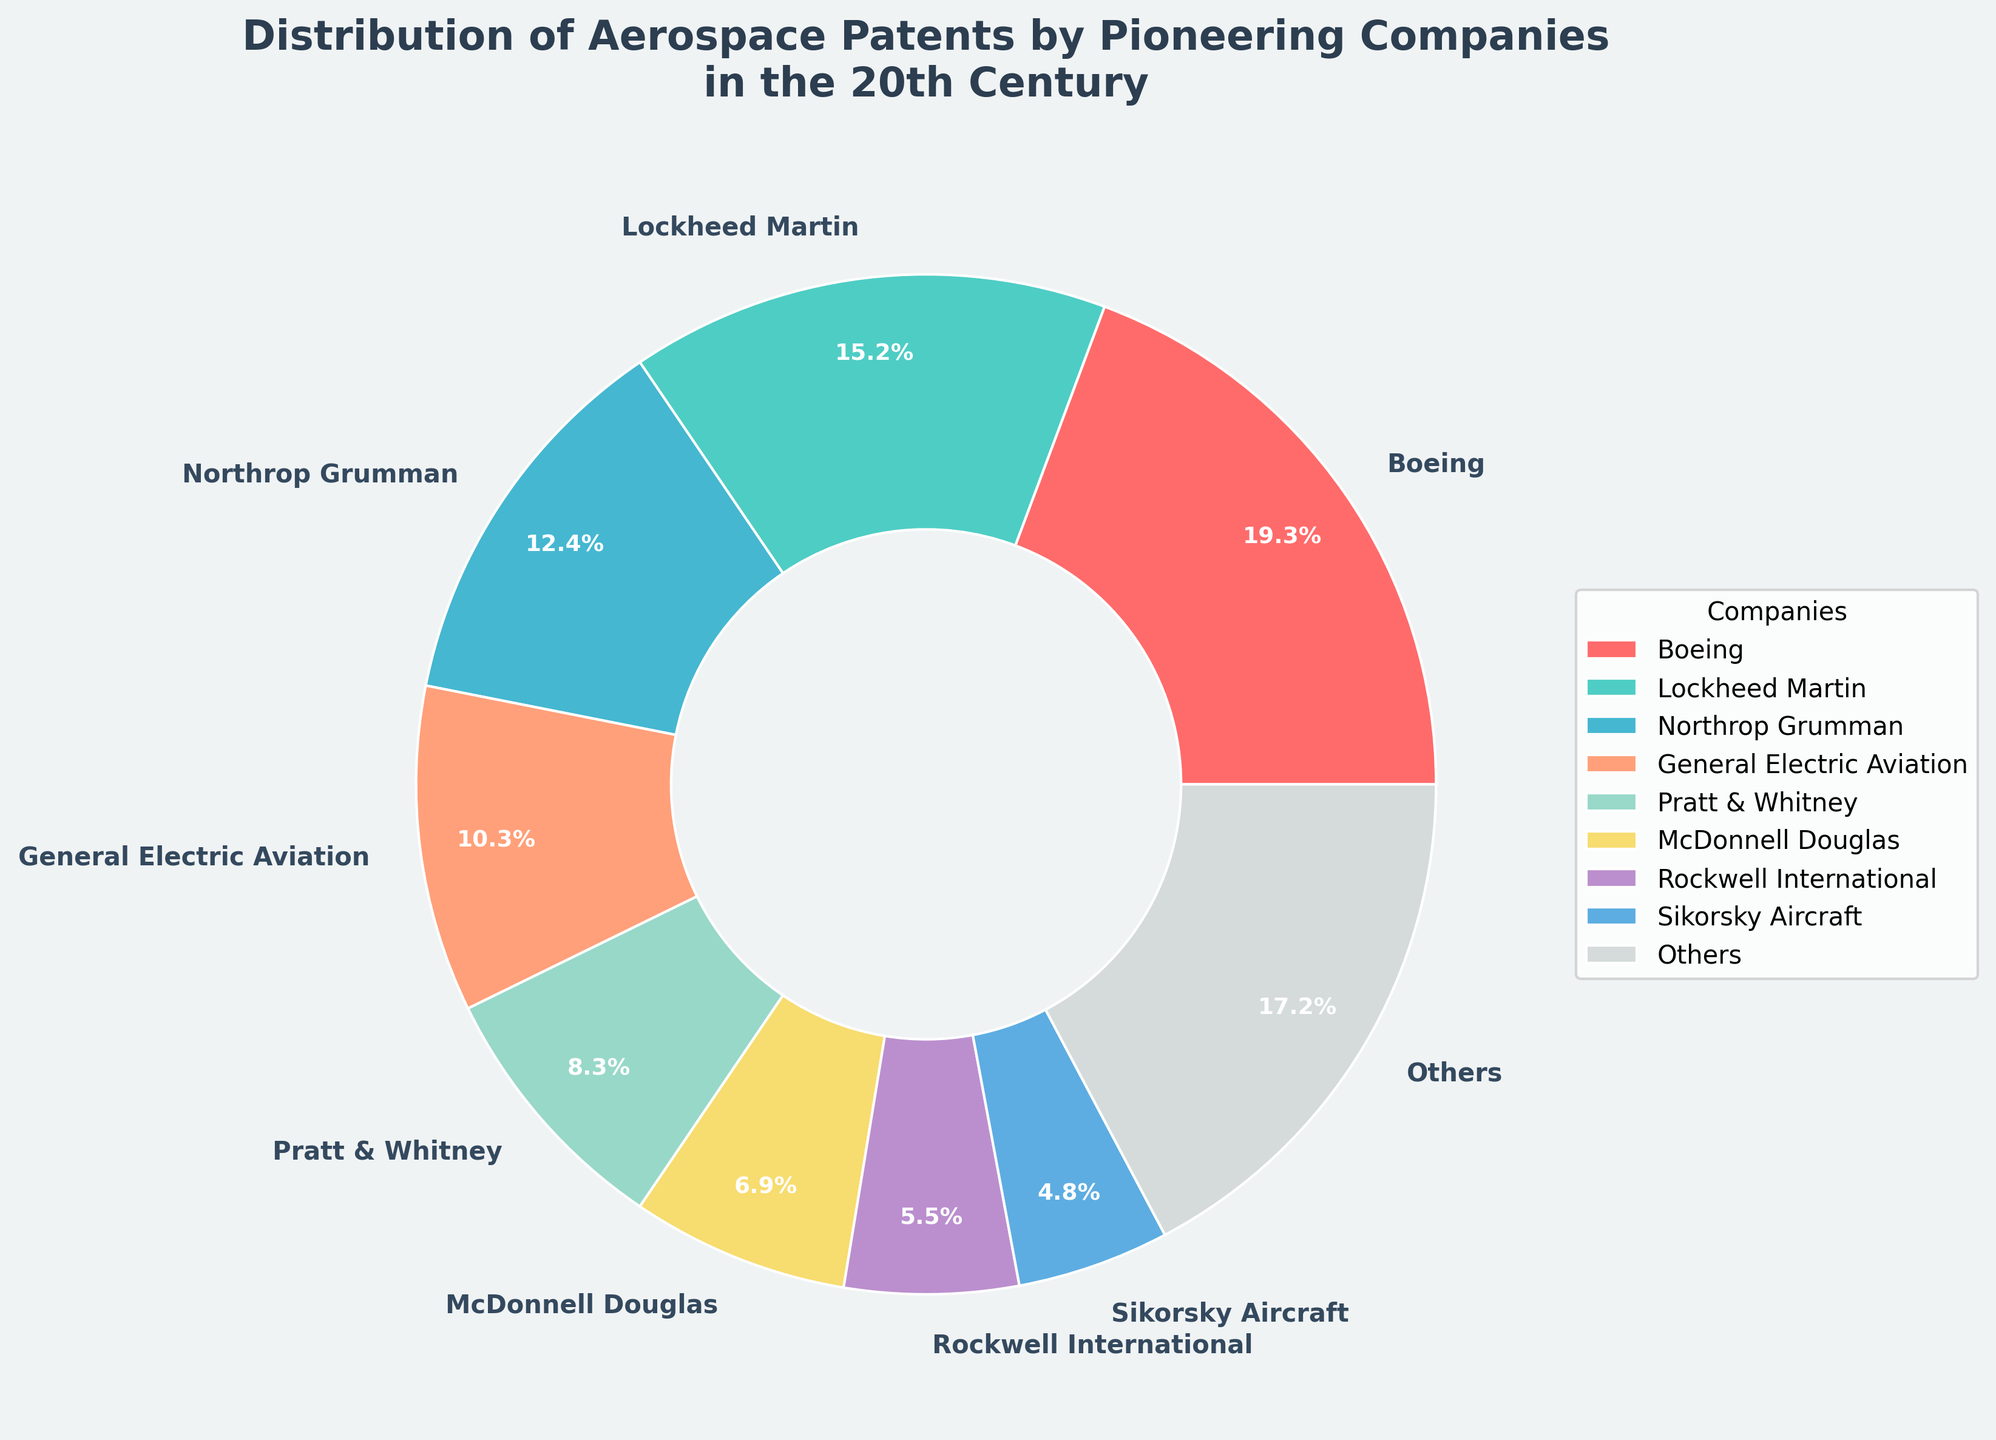Which company holds the largest share of aerospace patents? Look at the pie chart and identify the company segment that occupies the largest area. In this case, it is Boeing.
Answer: Boeing How many more patents does Lockheed Martin have than Northrop Grumman? Lockheed Martin holds 22 patents, while Northrop Grumman has 18. The difference is calculated as 22 - 18.
Answer: 4 What percentage of aerospace patents are held by "Others"? Sum the percentages of the companies outside the top 8 and look at the segment labeled "Others". These companies collectively hold 15.8% of the patents.
Answer: 15.8% Which companies are included in the "Others" category? The "Others" category includes all companies not in the top 8. These companies are Grumman Aircraft, Convair, Bell Aircraft, Douglas Aircraft Company, North American Aviation, Vought Aircraft, and Republic Aviation.
Answer: Grumman Aircraft, Convair, Bell Aircraft, Douglas Aircraft Company, North American Aviation, Vought Aircraft, Republic Aviation Is the percentage of patents held by McDonnell Douglas greater than that of Sikorsky Aircraft? Compare the pie chart segments for McDonnell Douglas and Sikorsky Aircraft. McDonnell Douglas has 5.6%, while Sikorsky Aircraft holds 3.9%.
Answer: Yes What is the combined percentage of patents held by General Electric Aviation and Pratt & Whitney? Add the percentages of General Electric Aviation and Pratt & Whitney from the pie chart. General Electric has 15.2%, and Pratt & Whitney has 12.2%. The sum is 15.2% + 12.2% = 27.4%.
Answer: 27.4% If you were to sum the percentages of patents held by Boeing, Lockheed Martin, and Northrop Grumman, what would it be? Sum the percentages shown in the pie chart for Boeing (28.0%), Lockheed Martin (22.0%), and Northrop Grumman (18.0%). The total is 28.0% + 22.0% + 18.0% = 68.0%.
Answer: 68.0% What color represents Rockwell International in the pie chart? Refer to the color-coded legend in the pie chart. The segment for Rockwell International is shown in green (sixth from the top).
Answer: Green Which company has the lowest number of patents among the top 8 companies? Look at the smallest segment within the top 8 companies in the pie chart. Sikorsky Aircraft has the smallest share among them with 3.9%.
Answer: Sikorsky Aircraft How many more patents does Boeing have compared to the total number of patents held by McDonnell Douglas and Rockwell International combined? Add the patents held by McDonnell Douglas and Rockwell International (10 + 8 = 18) and subtract from Boeing's 28 patents. The difference is 28 - 18.
Answer: 10 